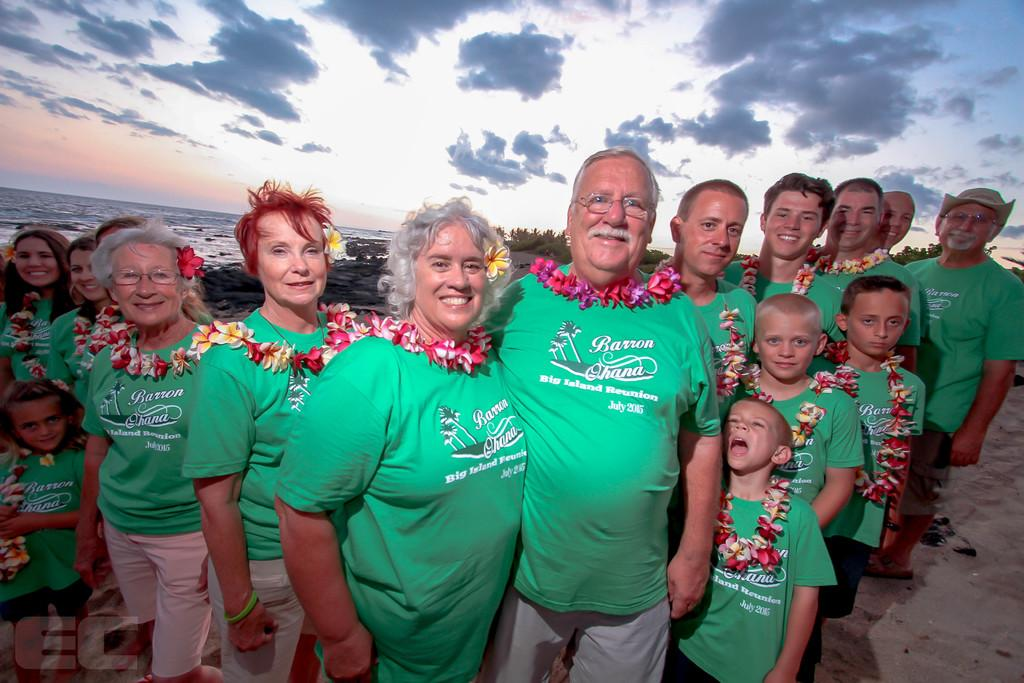What is happening in the image involving the group of people? The people in the image are holding flowers and standing while smiling. What can be seen in the background of the image? Water and the sky are visible in the background of the image. What might be the purpose of the flowers in the image? The flowers might be used for a celebration or event, as the people are holding them and smiling. Is there any indication of a watermark on the image? Yes, there is a watermark on the image. Where are the rabbits playing in the garden in the image? There are no rabbits or gardens present in the image; it features a group of people holding flowers and standing while smiling. What is the governor's opinion on the event in the image? There is no indication of a governor or an event in the image, so it is not possible to determine their opinion. 